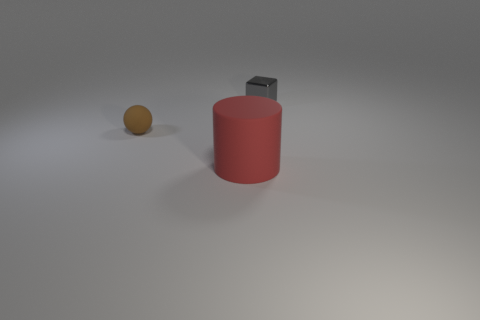Are there any brown matte things behind the big cylinder?
Your answer should be very brief. Yes. How many other objects are there of the same material as the small gray cube?
Keep it short and to the point. 0. There is a matte thing right of the tiny object that is in front of the tiny thing that is right of the small rubber object; what is its color?
Offer a very short reply. Red. There is a thing in front of the small thing that is on the left side of the gray metallic object; what is its shape?
Make the answer very short. Cylinder. Is the number of blocks on the right side of the big red rubber thing greater than the number of brown shiny objects?
Your answer should be compact. Yes. What number of objects are objects in front of the gray metallic object or metal things?
Offer a very short reply. 3. Is the number of shiny cubes greater than the number of big brown things?
Your answer should be compact. Yes. Are there any cubes of the same size as the brown matte thing?
Keep it short and to the point. Yes. What number of objects are tiny objects in front of the small shiny block or objects right of the brown rubber sphere?
Give a very brief answer. 3. What color is the matte object that is left of the matte thing that is on the right side of the matte sphere?
Ensure brevity in your answer.  Brown. 